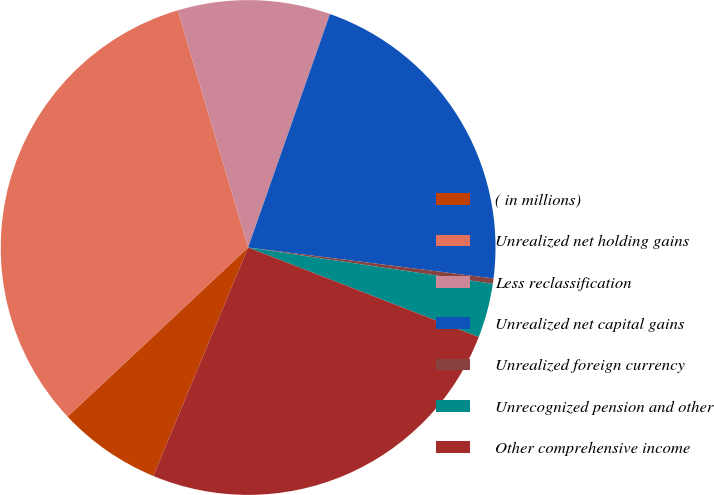<chart> <loc_0><loc_0><loc_500><loc_500><pie_chart><fcel>( in millions)<fcel>Unrealized net holding gains<fcel>Less reclassification<fcel>Unrealized net capital gains<fcel>Unrealized foreign currency<fcel>Unrecognized pension and other<fcel>Other comprehensive income<nl><fcel>6.76%<fcel>32.39%<fcel>9.96%<fcel>21.63%<fcel>0.35%<fcel>3.55%<fcel>25.36%<nl></chart> 